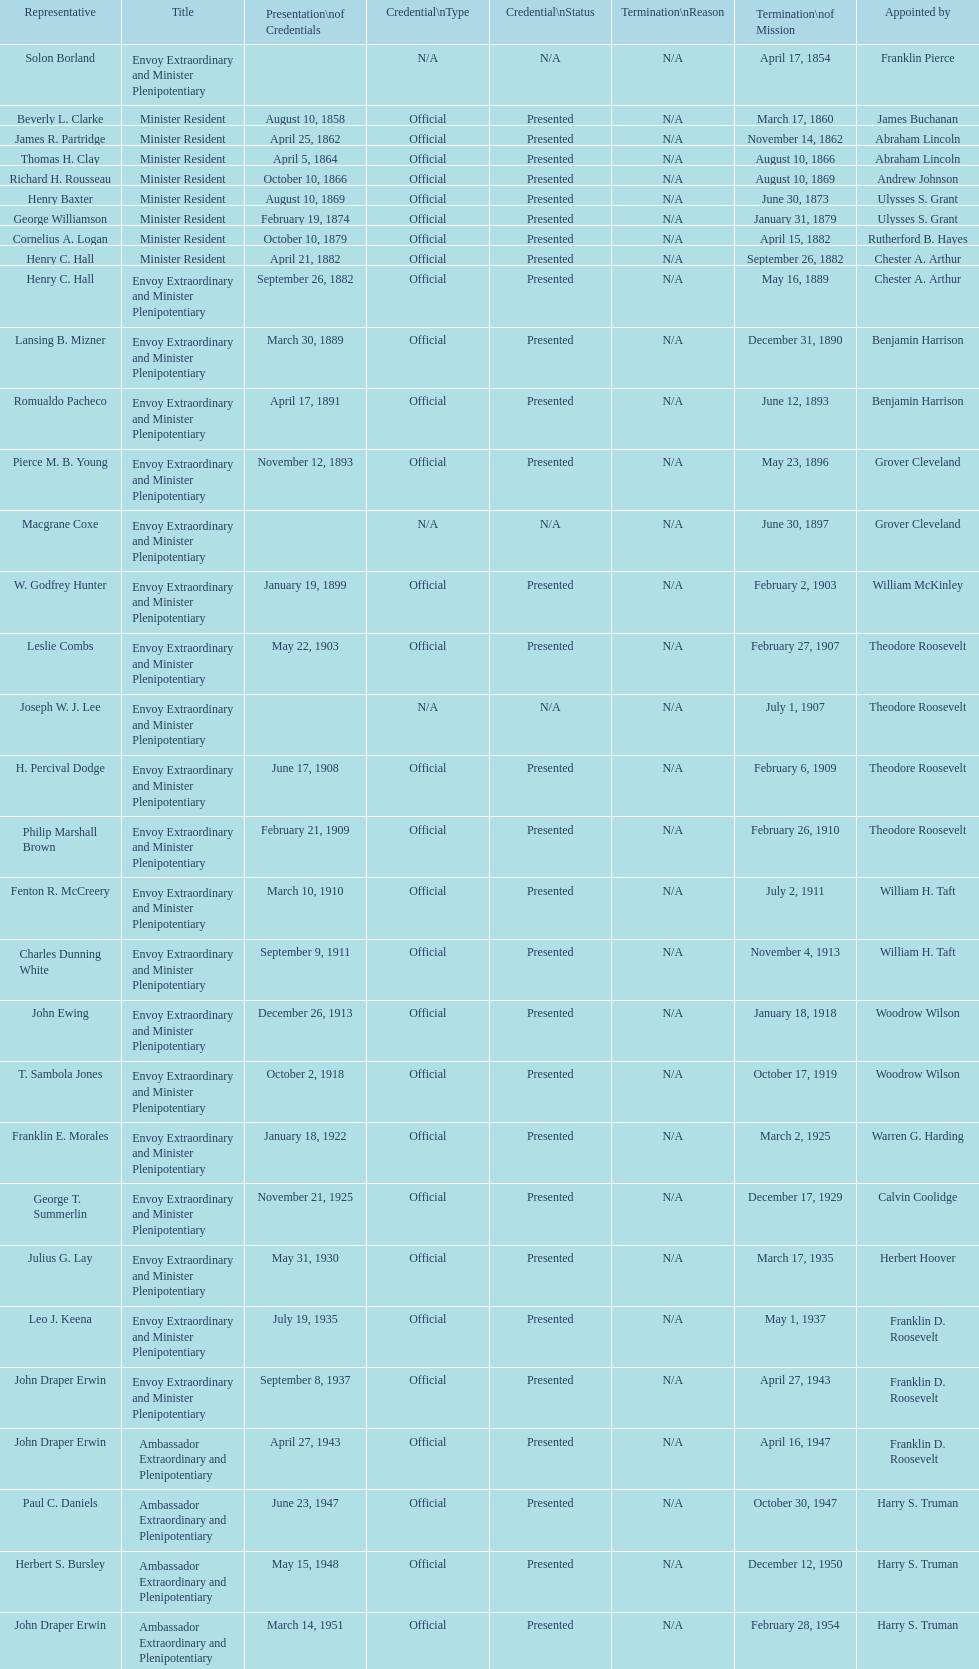How many representatives were appointed by theodore roosevelt? 4. 